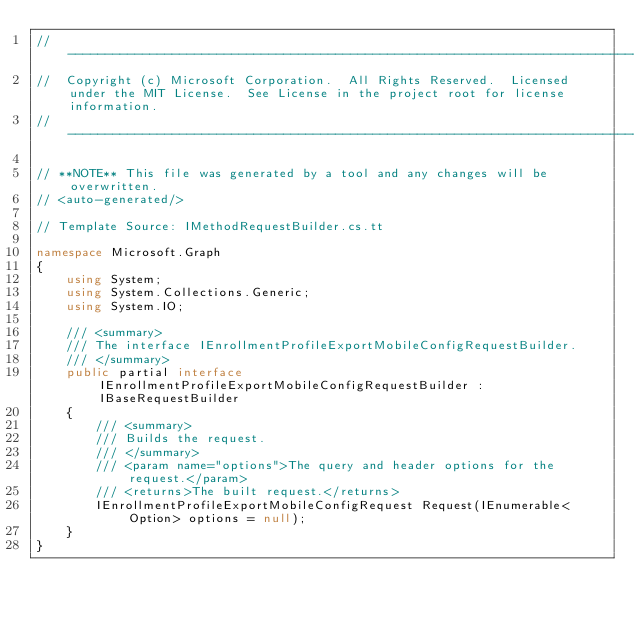<code> <loc_0><loc_0><loc_500><loc_500><_C#_>// ------------------------------------------------------------------------------
//  Copyright (c) Microsoft Corporation.  All Rights Reserved.  Licensed under the MIT License.  See License in the project root for license information.
// ------------------------------------------------------------------------------

// **NOTE** This file was generated by a tool and any changes will be overwritten.
// <auto-generated/>

// Template Source: IMethodRequestBuilder.cs.tt

namespace Microsoft.Graph
{
    using System;
    using System.Collections.Generic;
    using System.IO;

    /// <summary>
    /// The interface IEnrollmentProfileExportMobileConfigRequestBuilder.
    /// </summary>
    public partial interface IEnrollmentProfileExportMobileConfigRequestBuilder : IBaseRequestBuilder
    {
        /// <summary>
        /// Builds the request.
        /// </summary>
        /// <param name="options">The query and header options for the request.</param>
        /// <returns>The built request.</returns>
        IEnrollmentProfileExportMobileConfigRequest Request(IEnumerable<Option> options = null);
    }
}
</code> 